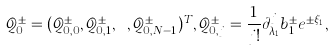<formula> <loc_0><loc_0><loc_500><loc_500>\mathcal { Q } ^ { \pm } _ { 0 } = ( \mathcal { Q } ^ { \pm } _ { 0 , 0 } , \mathcal { Q } ^ { \pm } _ { 0 , 1 } , \cdots , \mathcal { Q } ^ { \pm } _ { 0 , N - 1 } ) ^ { T } , \mathcal { Q } ^ { \pm } _ { 0 , j } = \frac { 1 } { j ! } \partial ^ { j } _ { \lambda _ { 1 } } b ^ { \pm } _ { 1 } e ^ { \pm \xi _ { 1 } } ,</formula> 